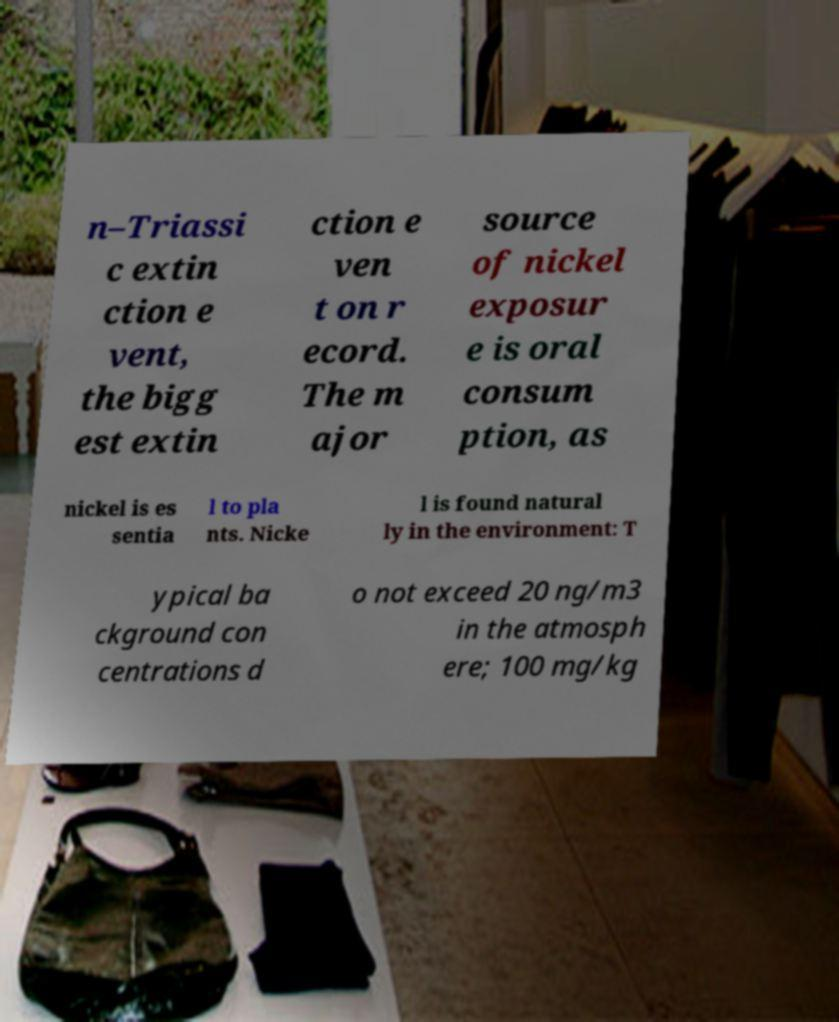Could you assist in decoding the text presented in this image and type it out clearly? n–Triassi c extin ction e vent, the bigg est extin ction e ven t on r ecord. The m ajor source of nickel exposur e is oral consum ption, as nickel is es sentia l to pla nts. Nicke l is found natural ly in the environment: T ypical ba ckground con centrations d o not exceed 20 ng/m3 in the atmosph ere; 100 mg/kg 